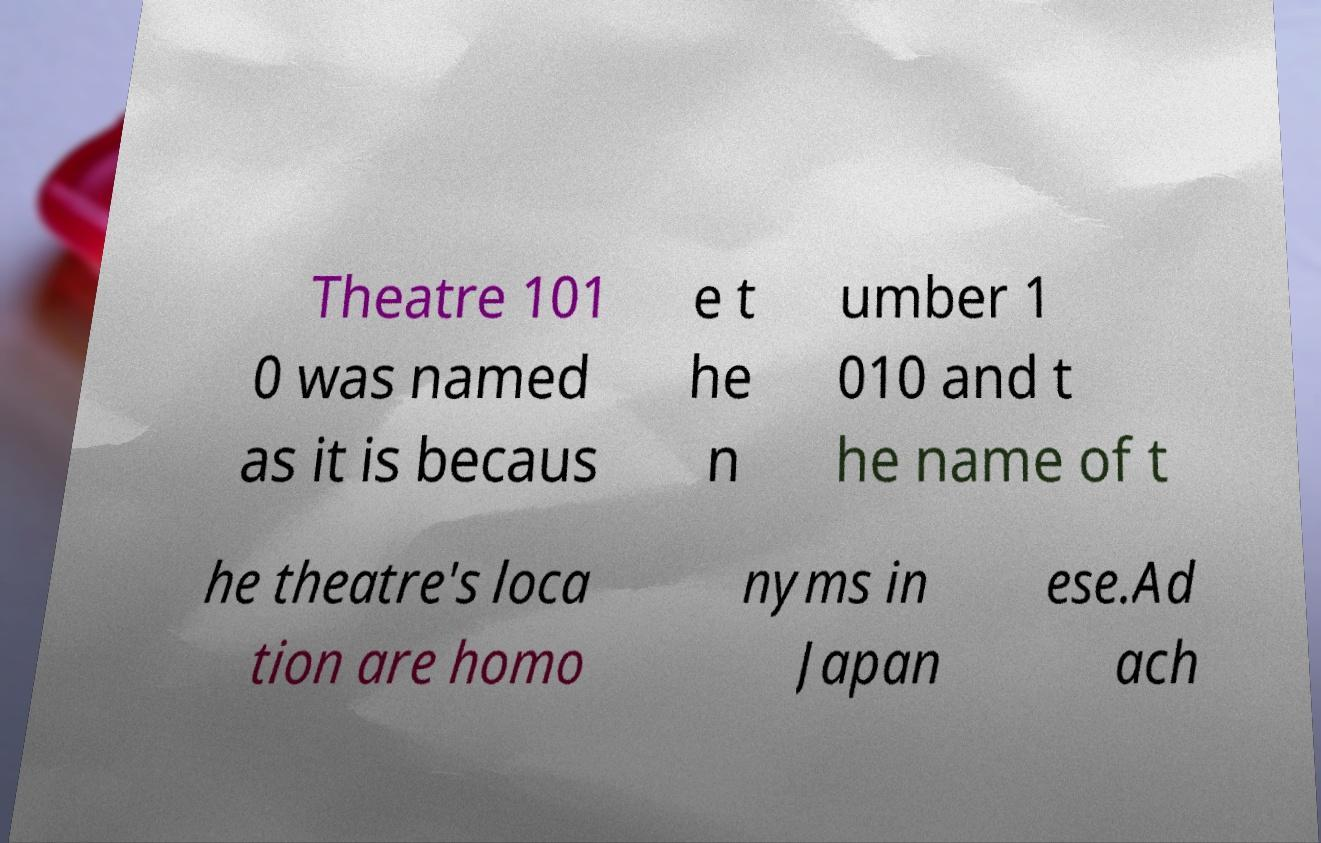Could you extract and type out the text from this image? Theatre 101 0 was named as it is becaus e t he n umber 1 010 and t he name of t he theatre's loca tion are homo nyms in Japan ese.Ad ach 